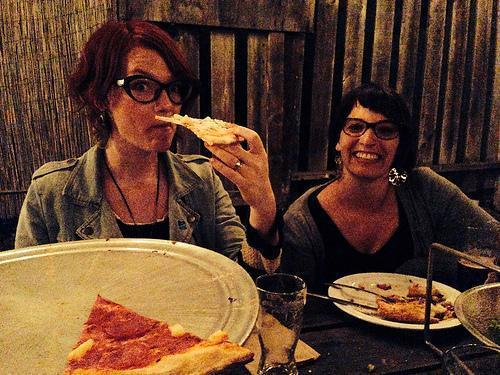How many women are there?
Give a very brief answer. 2. 